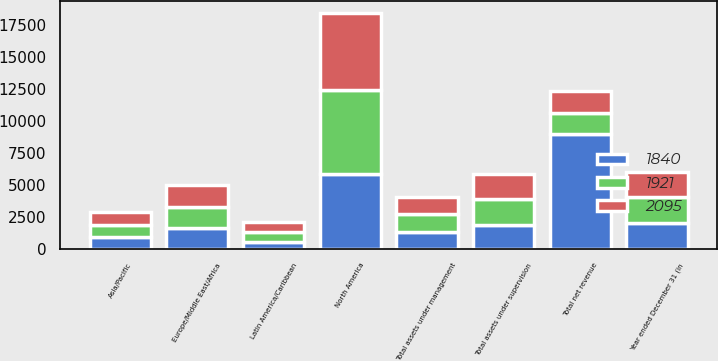<chart> <loc_0><loc_0><loc_500><loc_500><stacked_bar_chart><ecel><fcel>Year ended December 31 (in<fcel>Europe/Middle East/Africa<fcel>Asia/Pacific<fcel>Latin America/Caribbean<fcel>North America<fcel>Total net revenue<fcel>Total assets under management<fcel>Total assets under supervision<nl><fcel>1921<fcel>2012<fcel>1641<fcel>967<fcel>772<fcel>6566<fcel>1673<fcel>1426<fcel>2095<nl><fcel>2095<fcel>2011<fcel>1704<fcel>971<fcel>808<fcel>6060<fcel>1673<fcel>1336<fcel>1921<nl><fcel>1840<fcel>2010<fcel>1642<fcel>925<fcel>541<fcel>5876<fcel>8984<fcel>1298<fcel>1840<nl></chart> 